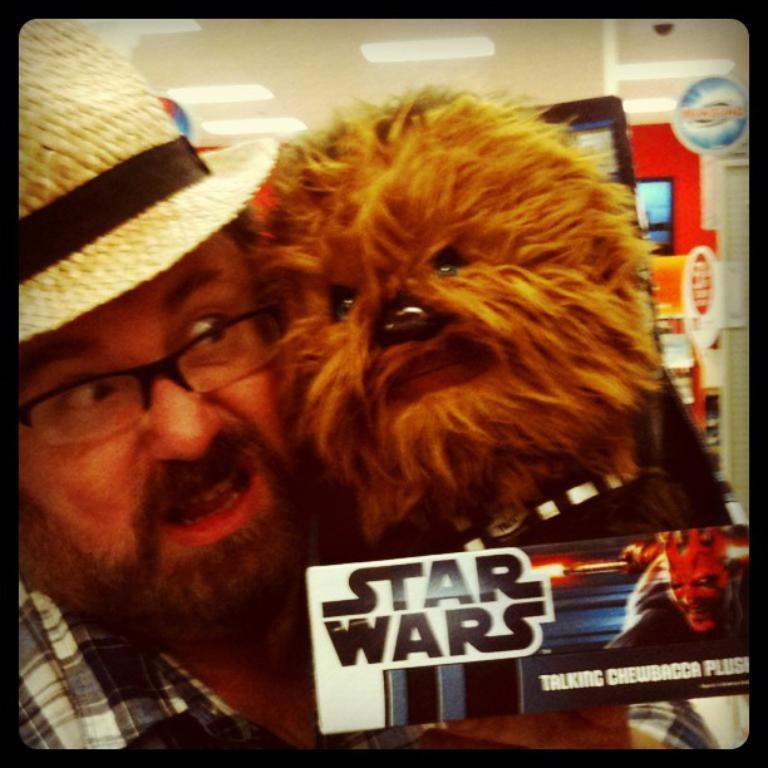Who is present in the image? There is a man and a dog in the image. What is the man wearing on his head? The man is wearing a hat. What type of clothing is the man wearing on his upper body? The man is wearing a shirt. Where is the sticker located in the image? The sticker is in the bottom right corner of the image. What can be read on the sticker? The sticker has text written on it. How many insects are crawling on the brick wall in the image? There are no insects or brick walls present in the image. What type of cake is being served for the birthday celebration in the image? There is no cake or birthday celebration depicted in the image. 